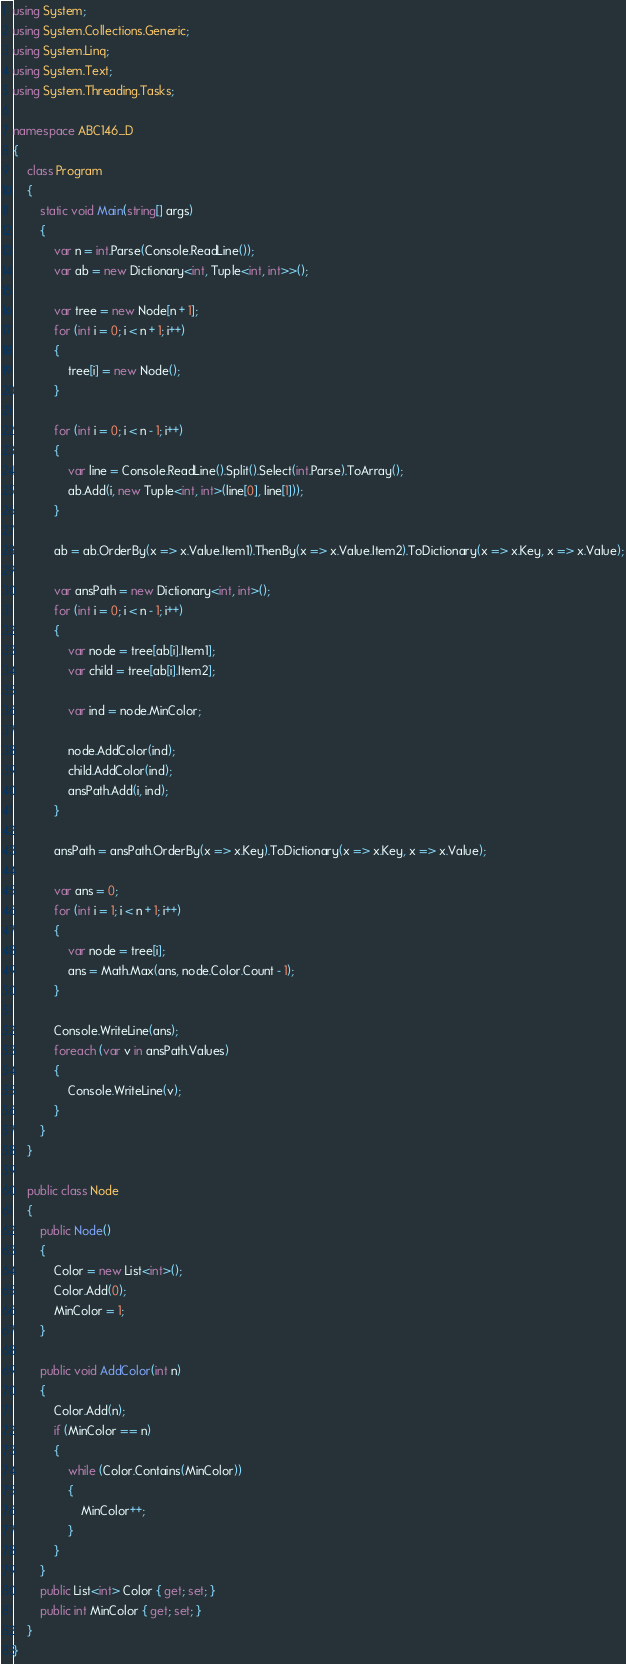Convert code to text. <code><loc_0><loc_0><loc_500><loc_500><_C#_>using System;
using System.Collections.Generic;
using System.Linq;
using System.Text;
using System.Threading.Tasks;

namespace ABC146_D
{
    class Program
    {
        static void Main(string[] args)
        {
            var n = int.Parse(Console.ReadLine());
            var ab = new Dictionary<int, Tuple<int, int>>();

            var tree = new Node[n + 1];
            for (int i = 0; i < n + 1; i++)
            {
                tree[i] = new Node();
            }

            for (int i = 0; i < n - 1; i++)
            {
                var line = Console.ReadLine().Split().Select(int.Parse).ToArray();
                ab.Add(i, new Tuple<int, int>(line[0], line[1]));
            }

            ab = ab.OrderBy(x => x.Value.Item1).ThenBy(x => x.Value.Item2).ToDictionary(x => x.Key, x => x.Value);

            var ansPath = new Dictionary<int, int>();
            for (int i = 0; i < n - 1; i++)
            {
                var node = tree[ab[i].Item1];
                var child = tree[ab[i].Item2];

                var ind = node.MinColor;

                node.AddColor(ind);
                child.AddColor(ind);
                ansPath.Add(i, ind);
            }

            ansPath = ansPath.OrderBy(x => x.Key).ToDictionary(x => x.Key, x => x.Value);

            var ans = 0;
            for (int i = 1; i < n + 1; i++)
            {
                var node = tree[i];
                ans = Math.Max(ans, node.Color.Count - 1);
            }

            Console.WriteLine(ans);
            foreach (var v in ansPath.Values)
            {
                Console.WriteLine(v);
            }
        }
    }

    public class Node
    {
        public Node()
        {
            Color = new List<int>();
            Color.Add(0);
            MinColor = 1;
        }

        public void AddColor(int n)
        {
            Color.Add(n);
            if (MinColor == n)
            {
                while (Color.Contains(MinColor))
                {
                    MinColor++;
                }
            }
        }
        public List<int> Color { get; set; }
        public int MinColor { get; set; }
    }
}
</code> 